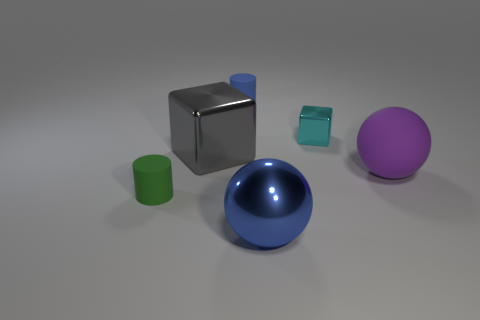Do the blue object behind the large purple matte sphere and the green object have the same shape? yes 